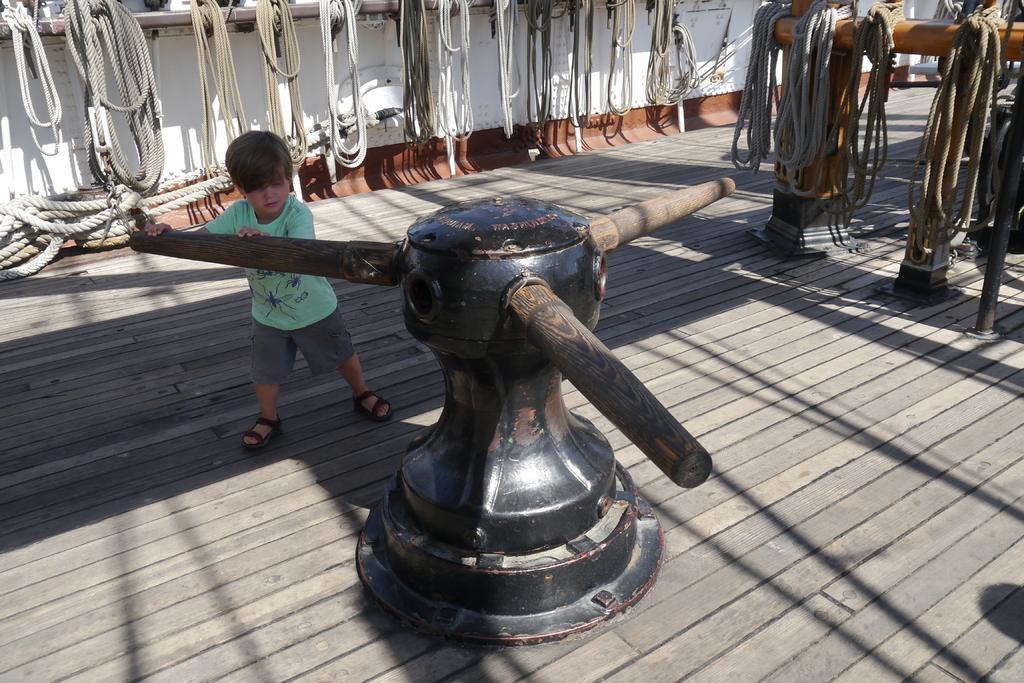Describe this image in one or two sentences. In the center of the image we can see a boy is holding a machine. In the background of the image we can see the wall, ropes, rods. At the bottom of the image we can see the floor. 